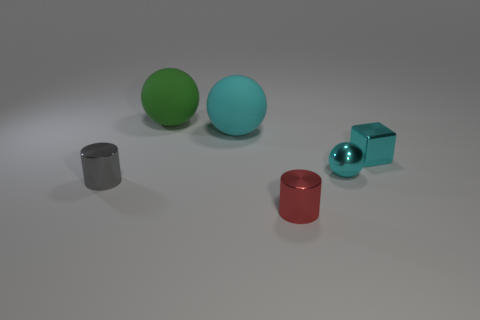Subtract all tiny cyan balls. How many balls are left? 2 Subtract 2 balls. How many balls are left? 1 Subtract all yellow cubes. How many cyan spheres are left? 2 Subtract all cyan balls. How many balls are left? 1 Add 1 cyan metallic things. How many objects exist? 7 Subtract all cylinders. How many objects are left? 4 Add 2 big green rubber spheres. How many big green rubber spheres are left? 3 Add 2 small metallic cylinders. How many small metallic cylinders exist? 4 Subtract 0 yellow blocks. How many objects are left? 6 Subtract all red cylinders. Subtract all brown blocks. How many cylinders are left? 1 